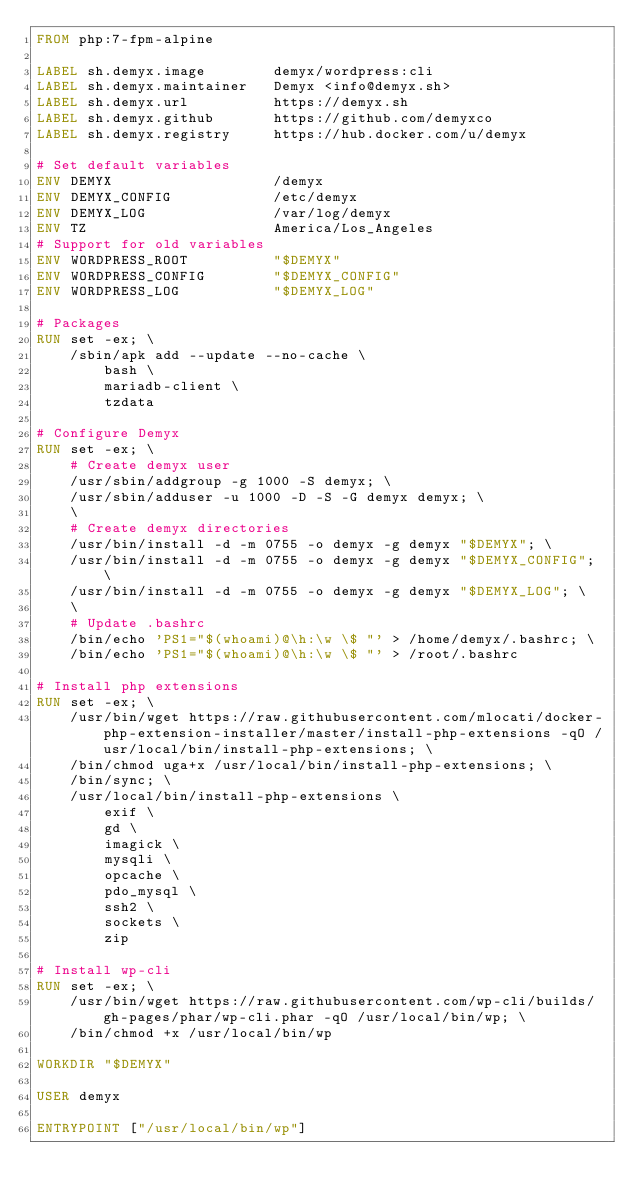Convert code to text. <code><loc_0><loc_0><loc_500><loc_500><_Dockerfile_>FROM php:7-fpm-alpine

LABEL sh.demyx.image        demyx/wordpress:cli
LABEL sh.demyx.maintainer   Demyx <info@demyx.sh>
LABEL sh.demyx.url          https://demyx.sh
LABEL sh.demyx.github       https://github.com/demyxco
LABEL sh.demyx.registry     https://hub.docker.com/u/demyx

# Set default variables
ENV DEMYX                   /demyx
ENV DEMYX_CONFIG            /etc/demyx
ENV DEMYX_LOG               /var/log/demyx
ENV TZ                      America/Los_Angeles
# Support for old variables
ENV WORDPRESS_ROOT          "$DEMYX"
ENV WORDPRESS_CONFIG        "$DEMYX_CONFIG"
ENV WORDPRESS_LOG           "$DEMYX_LOG"

# Packages
RUN set -ex; \
    /sbin/apk add --update --no-cache \
        bash \
        mariadb-client \
        tzdata

# Configure Demyx
RUN set -ex; \
    # Create demyx user
    /usr/sbin/addgroup -g 1000 -S demyx; \
    /usr/sbin/adduser -u 1000 -D -S -G demyx demyx; \
    \
    # Create demyx directories
    /usr/bin/install -d -m 0755 -o demyx -g demyx "$DEMYX"; \
    /usr/bin/install -d -m 0755 -o demyx -g demyx "$DEMYX_CONFIG"; \
    /usr/bin/install -d -m 0755 -o demyx -g demyx "$DEMYX_LOG"; \
    \
    # Update .bashrc
    /bin/echo 'PS1="$(whoami)@\h:\w \$ "' > /home/demyx/.bashrc; \
    /bin/echo 'PS1="$(whoami)@\h:\w \$ "' > /root/.bashrc

# Install php extensions
RUN set -ex; \
    /usr/bin/wget https://raw.githubusercontent.com/mlocati/docker-php-extension-installer/master/install-php-extensions -qO /usr/local/bin/install-php-extensions; \
    /bin/chmod uga+x /usr/local/bin/install-php-extensions; \
    /bin/sync; \
    /usr/local/bin/install-php-extensions \
        exif \
        gd \
        imagick \
        mysqli \
        opcache \
        pdo_mysql \
        ssh2 \
        sockets \
        zip

# Install wp-cli
RUN set -ex; \
    /usr/bin/wget https://raw.githubusercontent.com/wp-cli/builds/gh-pages/phar/wp-cli.phar -qO /usr/local/bin/wp; \
    /bin/chmod +x /usr/local/bin/wp

WORKDIR "$DEMYX"

USER demyx

ENTRYPOINT ["/usr/local/bin/wp"]
</code> 